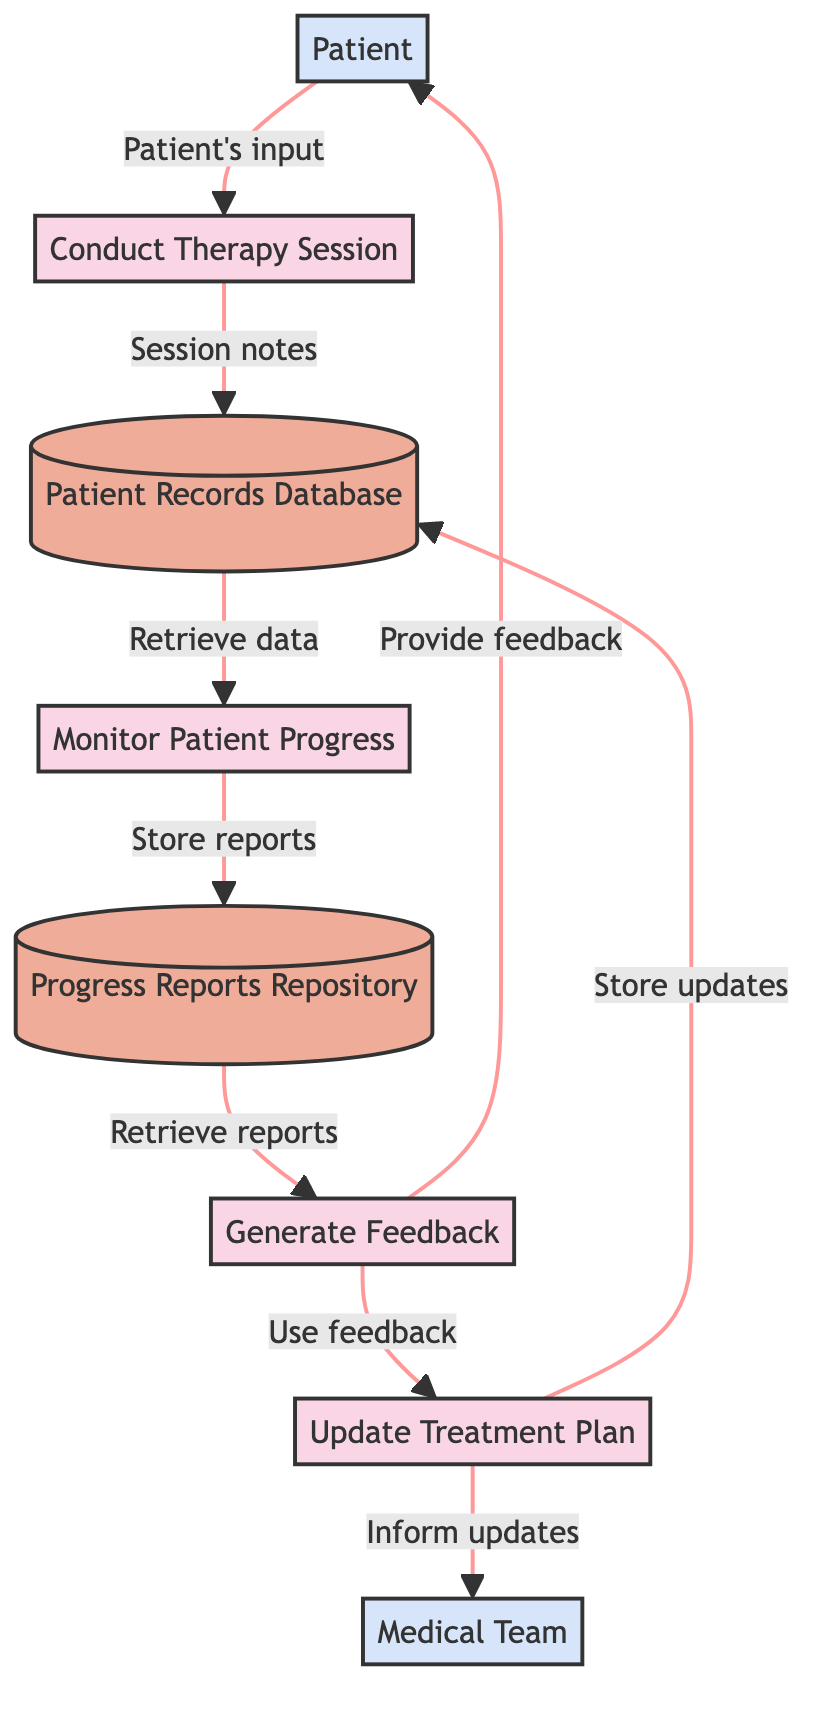What is the first process in the diagram? The first process is identified as "Conduct Therapy Session" (P1) in the diagram. It represents the starting point for patient interaction.
Answer: Conduct Therapy Session How many data stores are present in the diagram? There are two data stores: "Patient Records Database" (D1) and "Progress Reports Repository" (D2). This is determined by counting the nodes categorized as data stores.
Answer: 2 Who provides the input during the therapy session? The input during the therapy session comes from the "Patient" (E1), as indicated by the data flow from the Patient to the Conduct Therapy Session process.
Answer: Patient What flows from the Update Treatment Plan to the Medical Team? The flow from the Update Treatment Plan (P4) to the Medical Team (E2) is the updated treatment plan information based on feedback received during the process.
Answer: Inform updates What is the relationship between Monitor Patient Progress and Progress Reports Repository? The relationship is that the Monitor Patient Progress process (P2) stores the monitored progress reports in the Progress Reports Repository (D2), as indicated by the data flow between them.
Answer: Store reports What is the purpose of the Generate Feedback process? The purpose of the Generate Feedback process (P3) is to provide feedback to the patient based on the monitored progress reports retrieved from the Progress Reports Repository.
Answer: Provide feedback How does the Patient Records Database get updated? The Patient Records Database (D1) gets updated through two flows: storing session notes from the Conduct Therapy Session (P1) and storing updated treatment plans from the Update Treatment Plan (P4).
Answer: Store session notes and store updates Which external entity receives feedback based on progress? The "Patient" (E1) receives feedback based on progress, as indicated by the data flow from the Generate Feedback process (P3) to the Patient.
Answer: Patient 